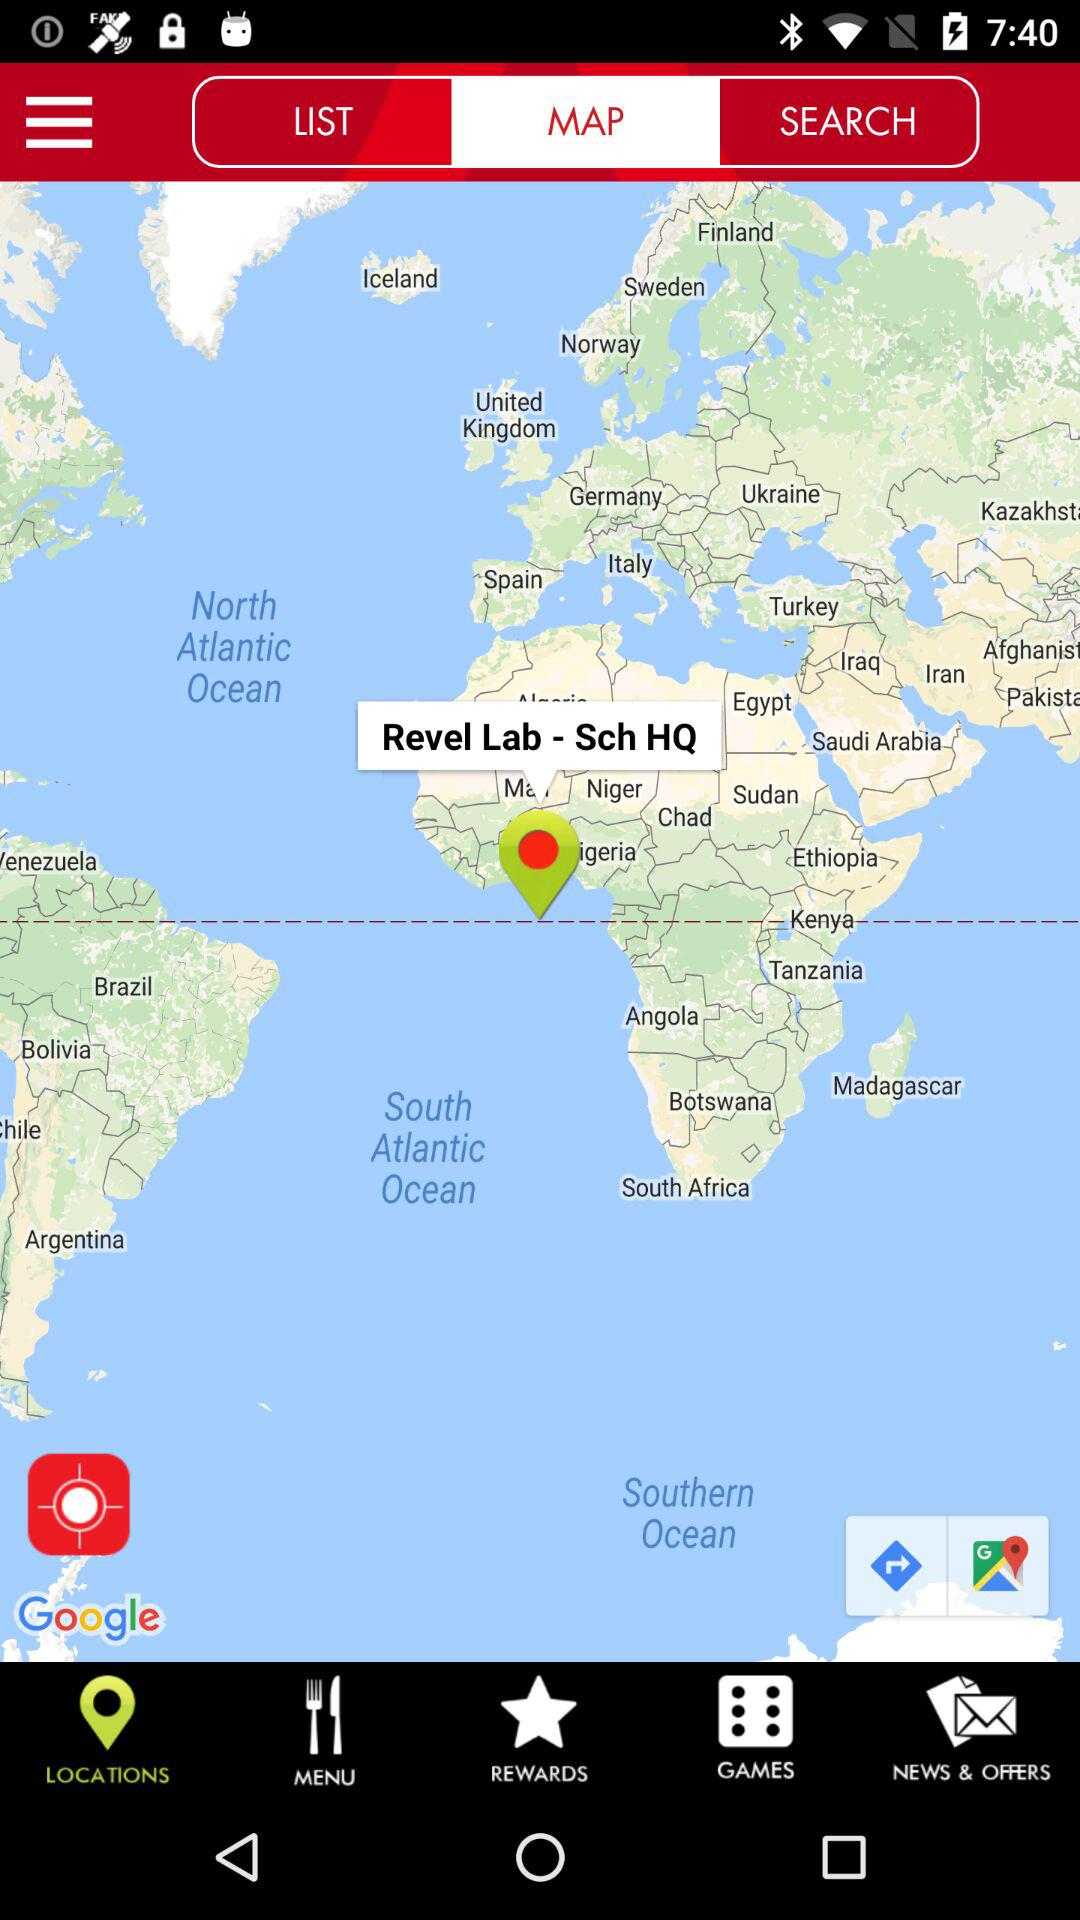Which tab is selected? The selected tabs are "MAP" and "LOCATIONS". 